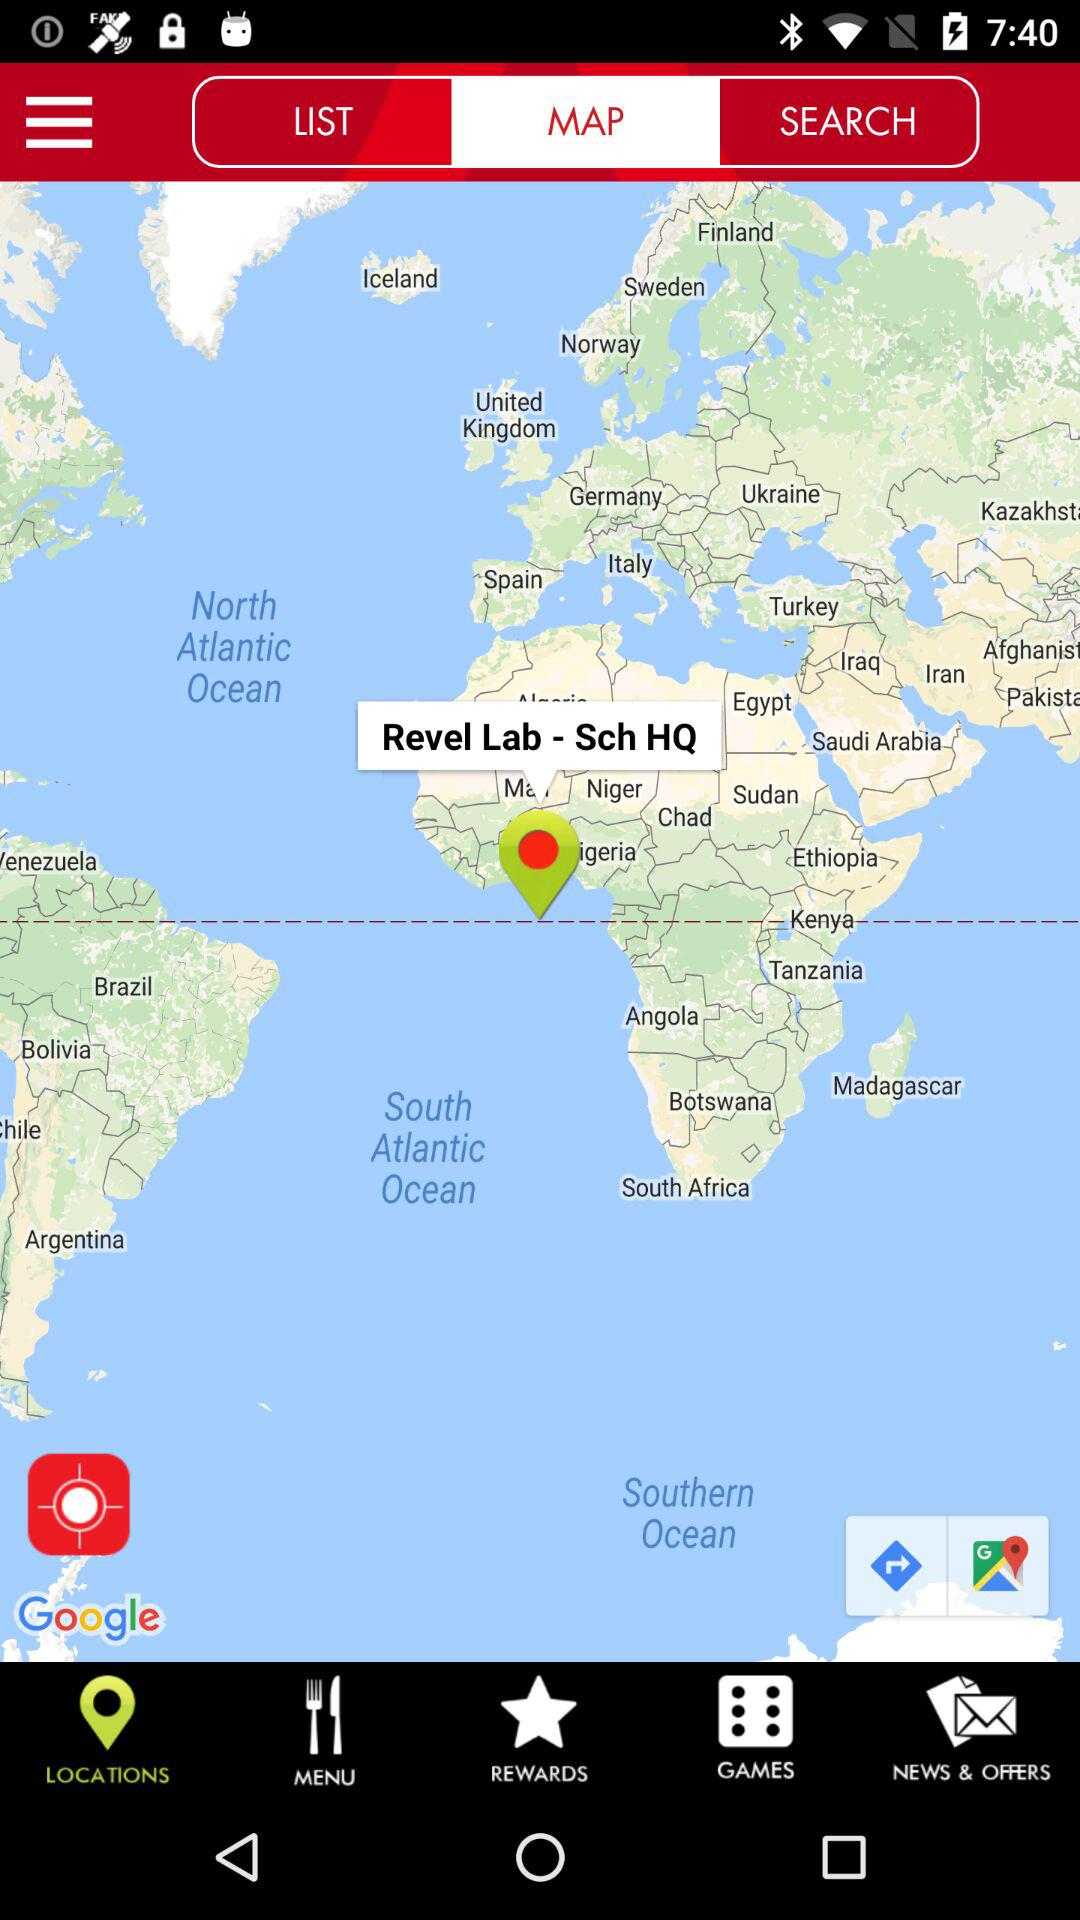Which tab is selected? The selected tabs are "MAP" and "LOCATIONS". 